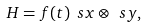<formula> <loc_0><loc_0><loc_500><loc_500>H = f ( t ) \ s x \otimes \ s y ,</formula> 